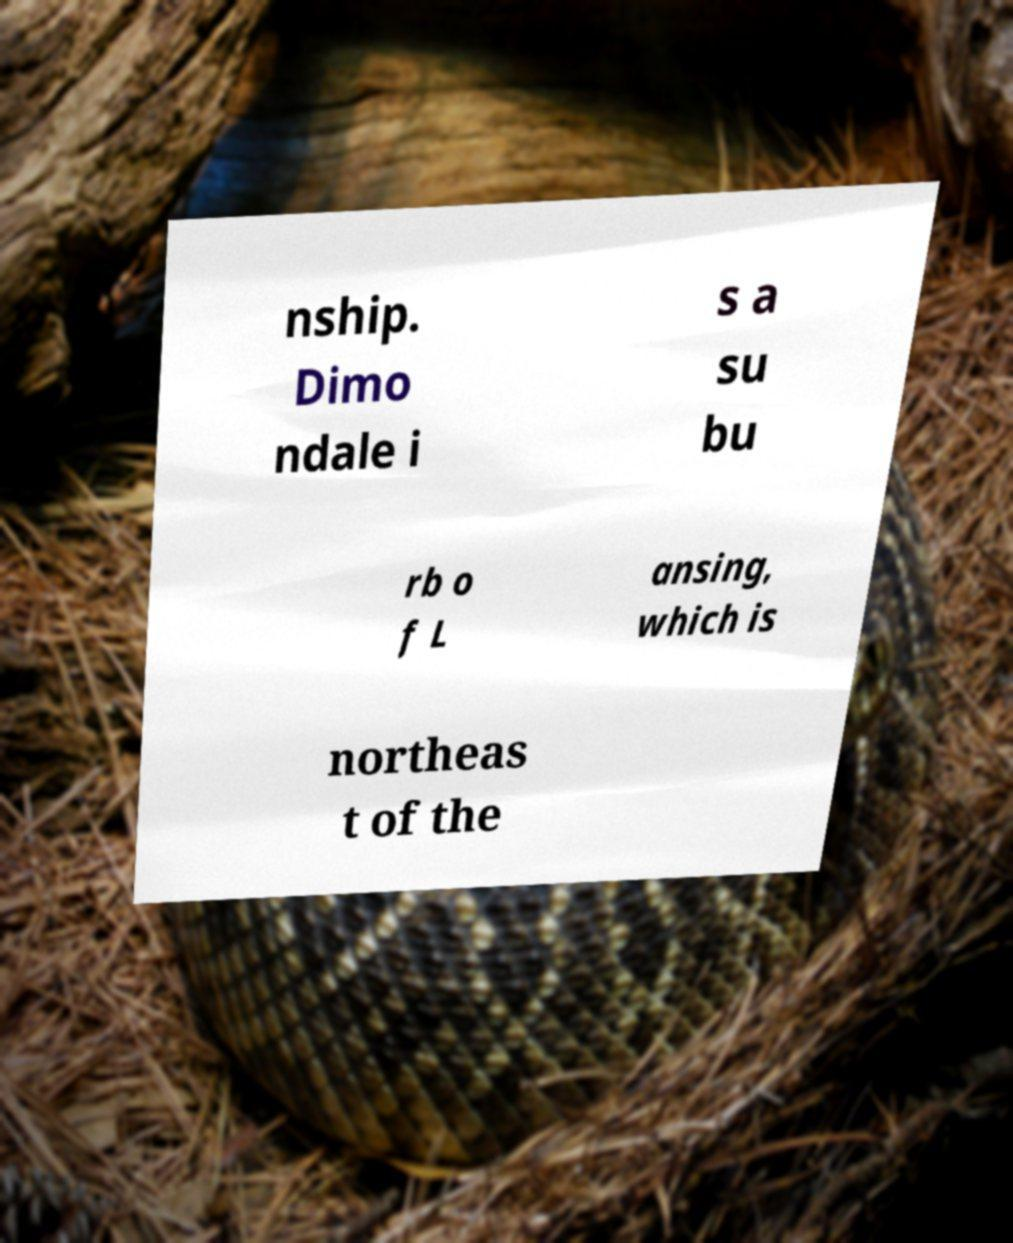What messages or text are displayed in this image? I need them in a readable, typed format. nship. Dimo ndale i s a su bu rb o f L ansing, which is northeas t of the 